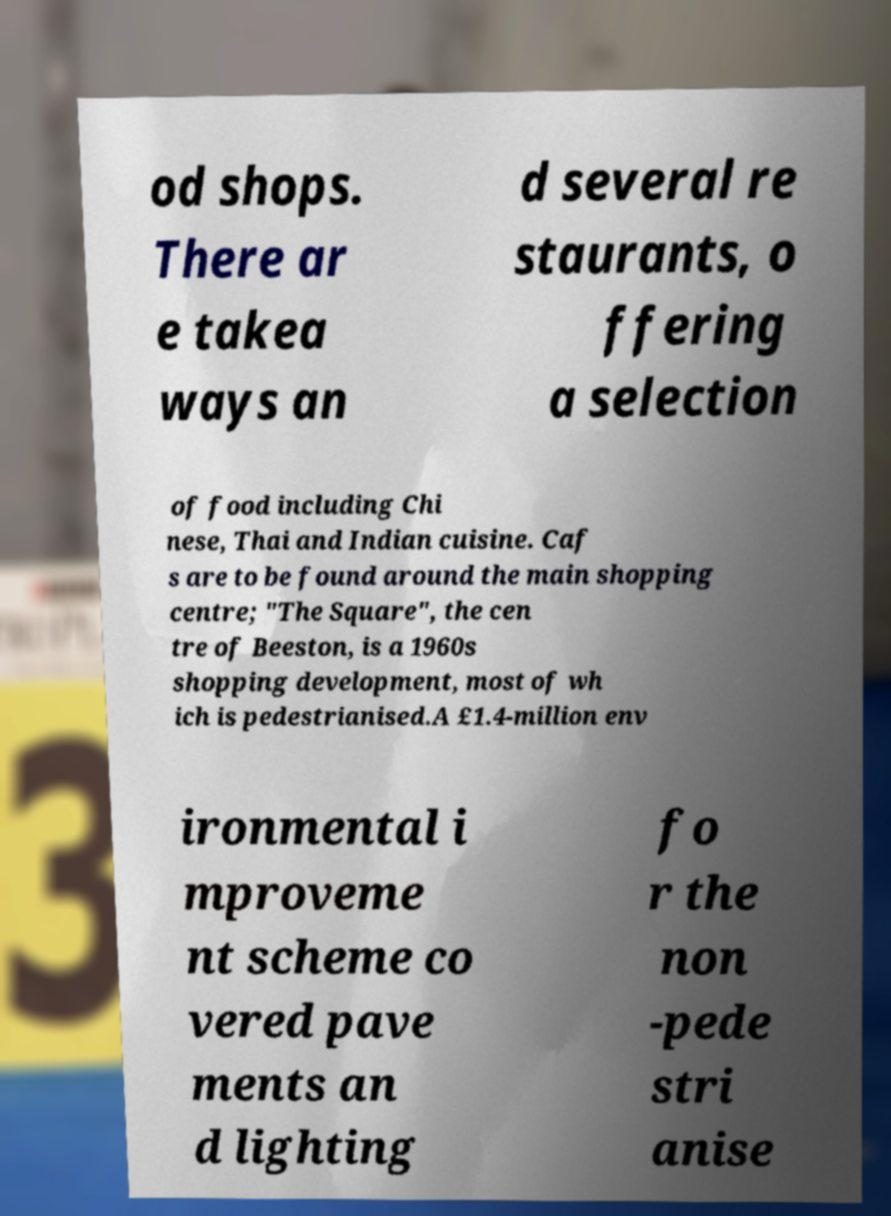Can you read and provide the text displayed in the image?This photo seems to have some interesting text. Can you extract and type it out for me? od shops. There ar e takea ways an d several re staurants, o ffering a selection of food including Chi nese, Thai and Indian cuisine. Caf s are to be found around the main shopping centre; "The Square", the cen tre of Beeston, is a 1960s shopping development, most of wh ich is pedestrianised.A £1.4-million env ironmental i mproveme nt scheme co vered pave ments an d lighting fo r the non -pede stri anise 